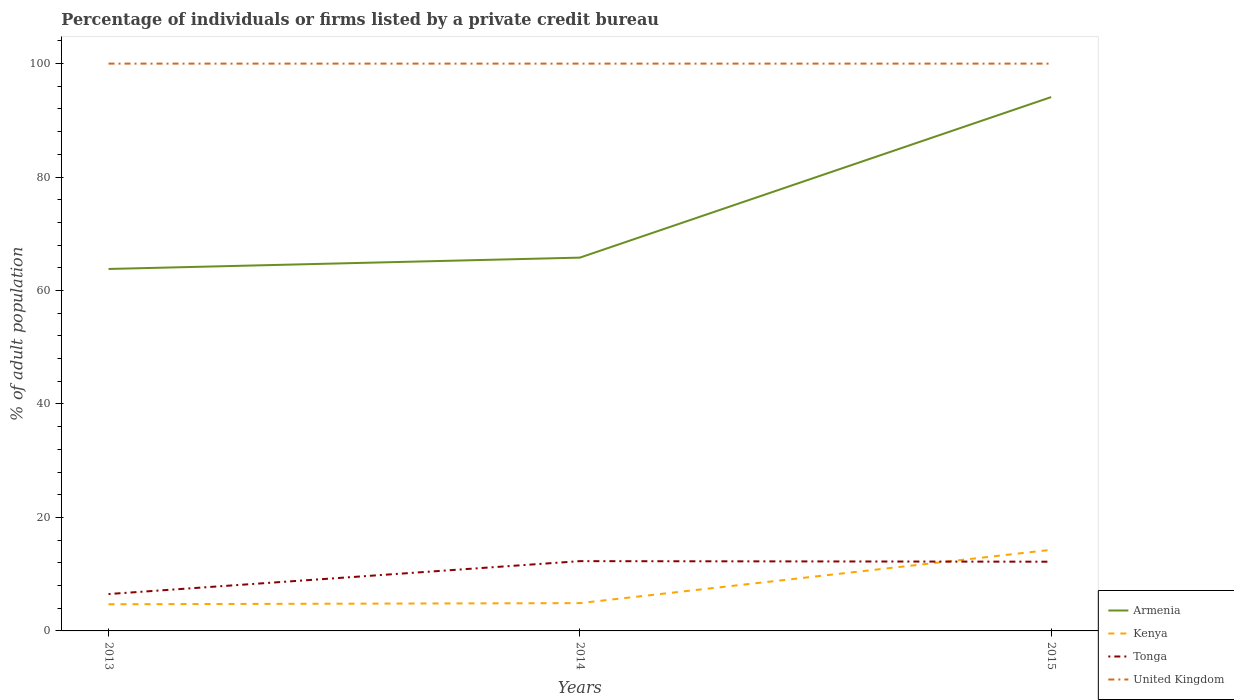Does the line corresponding to Armenia intersect with the line corresponding to United Kingdom?
Offer a very short reply. No. Is the number of lines equal to the number of legend labels?
Your answer should be compact. Yes. Across all years, what is the maximum percentage of population listed by a private credit bureau in Armenia?
Offer a terse response. 63.8. In which year was the percentage of population listed by a private credit bureau in Tonga maximum?
Give a very brief answer. 2013. Is the percentage of population listed by a private credit bureau in Armenia strictly greater than the percentage of population listed by a private credit bureau in United Kingdom over the years?
Give a very brief answer. Yes. What is the difference between two consecutive major ticks on the Y-axis?
Ensure brevity in your answer.  20. Are the values on the major ticks of Y-axis written in scientific E-notation?
Offer a terse response. No. Does the graph contain any zero values?
Your answer should be compact. No. Does the graph contain grids?
Make the answer very short. No. Where does the legend appear in the graph?
Your response must be concise. Bottom right. How many legend labels are there?
Ensure brevity in your answer.  4. What is the title of the graph?
Your answer should be very brief. Percentage of individuals or firms listed by a private credit bureau. What is the label or title of the Y-axis?
Make the answer very short. % of adult population. What is the % of adult population of Armenia in 2013?
Provide a short and direct response. 63.8. What is the % of adult population in United Kingdom in 2013?
Your response must be concise. 100. What is the % of adult population of Armenia in 2014?
Provide a succinct answer. 65.8. What is the % of adult population in Kenya in 2014?
Give a very brief answer. 4.9. What is the % of adult population of Tonga in 2014?
Offer a very short reply. 12.3. What is the % of adult population in United Kingdom in 2014?
Keep it short and to the point. 100. What is the % of adult population of Armenia in 2015?
Your answer should be very brief. 94.1. What is the % of adult population of Kenya in 2015?
Provide a succinct answer. 14.3. What is the % of adult population in Tonga in 2015?
Your answer should be very brief. 12.2. Across all years, what is the maximum % of adult population in Armenia?
Ensure brevity in your answer.  94.1. Across all years, what is the maximum % of adult population in Kenya?
Offer a terse response. 14.3. Across all years, what is the maximum % of adult population in Tonga?
Give a very brief answer. 12.3. Across all years, what is the maximum % of adult population of United Kingdom?
Offer a terse response. 100. Across all years, what is the minimum % of adult population in Armenia?
Your answer should be very brief. 63.8. Across all years, what is the minimum % of adult population of Kenya?
Your answer should be very brief. 4.7. Across all years, what is the minimum % of adult population of Tonga?
Your answer should be very brief. 6.5. What is the total % of adult population in Armenia in the graph?
Provide a succinct answer. 223.7. What is the total % of adult population of Kenya in the graph?
Offer a terse response. 23.9. What is the total % of adult population of Tonga in the graph?
Your answer should be compact. 31. What is the total % of adult population in United Kingdom in the graph?
Your response must be concise. 300. What is the difference between the % of adult population in Kenya in 2013 and that in 2014?
Keep it short and to the point. -0.2. What is the difference between the % of adult population of United Kingdom in 2013 and that in 2014?
Keep it short and to the point. 0. What is the difference between the % of adult population of Armenia in 2013 and that in 2015?
Provide a short and direct response. -30.3. What is the difference between the % of adult population of United Kingdom in 2013 and that in 2015?
Make the answer very short. 0. What is the difference between the % of adult population of Armenia in 2014 and that in 2015?
Your response must be concise. -28.3. What is the difference between the % of adult population in United Kingdom in 2014 and that in 2015?
Ensure brevity in your answer.  0. What is the difference between the % of adult population of Armenia in 2013 and the % of adult population of Kenya in 2014?
Ensure brevity in your answer.  58.9. What is the difference between the % of adult population in Armenia in 2013 and the % of adult population in Tonga in 2014?
Ensure brevity in your answer.  51.5. What is the difference between the % of adult population of Armenia in 2013 and the % of adult population of United Kingdom in 2014?
Provide a succinct answer. -36.2. What is the difference between the % of adult population of Kenya in 2013 and the % of adult population of United Kingdom in 2014?
Provide a succinct answer. -95.3. What is the difference between the % of adult population in Tonga in 2013 and the % of adult population in United Kingdom in 2014?
Make the answer very short. -93.5. What is the difference between the % of adult population in Armenia in 2013 and the % of adult population in Kenya in 2015?
Provide a short and direct response. 49.5. What is the difference between the % of adult population of Armenia in 2013 and the % of adult population of Tonga in 2015?
Your answer should be compact. 51.6. What is the difference between the % of adult population of Armenia in 2013 and the % of adult population of United Kingdom in 2015?
Your response must be concise. -36.2. What is the difference between the % of adult population in Kenya in 2013 and the % of adult population in United Kingdom in 2015?
Ensure brevity in your answer.  -95.3. What is the difference between the % of adult population in Tonga in 2013 and the % of adult population in United Kingdom in 2015?
Your answer should be compact. -93.5. What is the difference between the % of adult population in Armenia in 2014 and the % of adult population in Kenya in 2015?
Provide a short and direct response. 51.5. What is the difference between the % of adult population in Armenia in 2014 and the % of adult population in Tonga in 2015?
Your response must be concise. 53.6. What is the difference between the % of adult population in Armenia in 2014 and the % of adult population in United Kingdom in 2015?
Your answer should be compact. -34.2. What is the difference between the % of adult population of Kenya in 2014 and the % of adult population of Tonga in 2015?
Your answer should be very brief. -7.3. What is the difference between the % of adult population in Kenya in 2014 and the % of adult population in United Kingdom in 2015?
Make the answer very short. -95.1. What is the difference between the % of adult population in Tonga in 2014 and the % of adult population in United Kingdom in 2015?
Your response must be concise. -87.7. What is the average % of adult population of Armenia per year?
Offer a terse response. 74.57. What is the average % of adult population of Kenya per year?
Provide a short and direct response. 7.97. What is the average % of adult population in Tonga per year?
Offer a terse response. 10.33. In the year 2013, what is the difference between the % of adult population in Armenia and % of adult population in Kenya?
Your answer should be compact. 59.1. In the year 2013, what is the difference between the % of adult population of Armenia and % of adult population of Tonga?
Offer a very short reply. 57.3. In the year 2013, what is the difference between the % of adult population of Armenia and % of adult population of United Kingdom?
Keep it short and to the point. -36.2. In the year 2013, what is the difference between the % of adult population in Kenya and % of adult population in United Kingdom?
Make the answer very short. -95.3. In the year 2013, what is the difference between the % of adult population in Tonga and % of adult population in United Kingdom?
Keep it short and to the point. -93.5. In the year 2014, what is the difference between the % of adult population in Armenia and % of adult population in Kenya?
Your response must be concise. 60.9. In the year 2014, what is the difference between the % of adult population of Armenia and % of adult population of Tonga?
Offer a very short reply. 53.5. In the year 2014, what is the difference between the % of adult population of Armenia and % of adult population of United Kingdom?
Your answer should be very brief. -34.2. In the year 2014, what is the difference between the % of adult population in Kenya and % of adult population in Tonga?
Your answer should be compact. -7.4. In the year 2014, what is the difference between the % of adult population in Kenya and % of adult population in United Kingdom?
Your response must be concise. -95.1. In the year 2014, what is the difference between the % of adult population in Tonga and % of adult population in United Kingdom?
Offer a terse response. -87.7. In the year 2015, what is the difference between the % of adult population of Armenia and % of adult population of Kenya?
Give a very brief answer. 79.8. In the year 2015, what is the difference between the % of adult population in Armenia and % of adult population in Tonga?
Offer a terse response. 81.9. In the year 2015, what is the difference between the % of adult population of Armenia and % of adult population of United Kingdom?
Provide a short and direct response. -5.9. In the year 2015, what is the difference between the % of adult population of Kenya and % of adult population of Tonga?
Give a very brief answer. 2.1. In the year 2015, what is the difference between the % of adult population in Kenya and % of adult population in United Kingdom?
Your answer should be compact. -85.7. In the year 2015, what is the difference between the % of adult population in Tonga and % of adult population in United Kingdom?
Offer a terse response. -87.8. What is the ratio of the % of adult population of Armenia in 2013 to that in 2014?
Offer a terse response. 0.97. What is the ratio of the % of adult population of Kenya in 2013 to that in 2014?
Offer a terse response. 0.96. What is the ratio of the % of adult population in Tonga in 2013 to that in 2014?
Provide a succinct answer. 0.53. What is the ratio of the % of adult population of Armenia in 2013 to that in 2015?
Make the answer very short. 0.68. What is the ratio of the % of adult population in Kenya in 2013 to that in 2015?
Give a very brief answer. 0.33. What is the ratio of the % of adult population of Tonga in 2013 to that in 2015?
Provide a short and direct response. 0.53. What is the ratio of the % of adult population in Armenia in 2014 to that in 2015?
Provide a succinct answer. 0.7. What is the ratio of the % of adult population of Kenya in 2014 to that in 2015?
Give a very brief answer. 0.34. What is the ratio of the % of adult population in Tonga in 2014 to that in 2015?
Offer a very short reply. 1.01. What is the ratio of the % of adult population of United Kingdom in 2014 to that in 2015?
Offer a terse response. 1. What is the difference between the highest and the second highest % of adult population of Armenia?
Ensure brevity in your answer.  28.3. What is the difference between the highest and the second highest % of adult population of Kenya?
Make the answer very short. 9.4. What is the difference between the highest and the second highest % of adult population in Tonga?
Make the answer very short. 0.1. What is the difference between the highest and the lowest % of adult population in Armenia?
Provide a short and direct response. 30.3. What is the difference between the highest and the lowest % of adult population of Kenya?
Your answer should be very brief. 9.6. What is the difference between the highest and the lowest % of adult population in United Kingdom?
Make the answer very short. 0. 